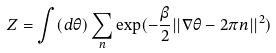Convert formula to latex. <formula><loc_0><loc_0><loc_500><loc_500>Z = \int ( d \theta ) \sum _ { n } \exp ( - \frac { \beta } { 2 } | | \nabla \theta - 2 \pi n | | ^ { 2 } )</formula> 